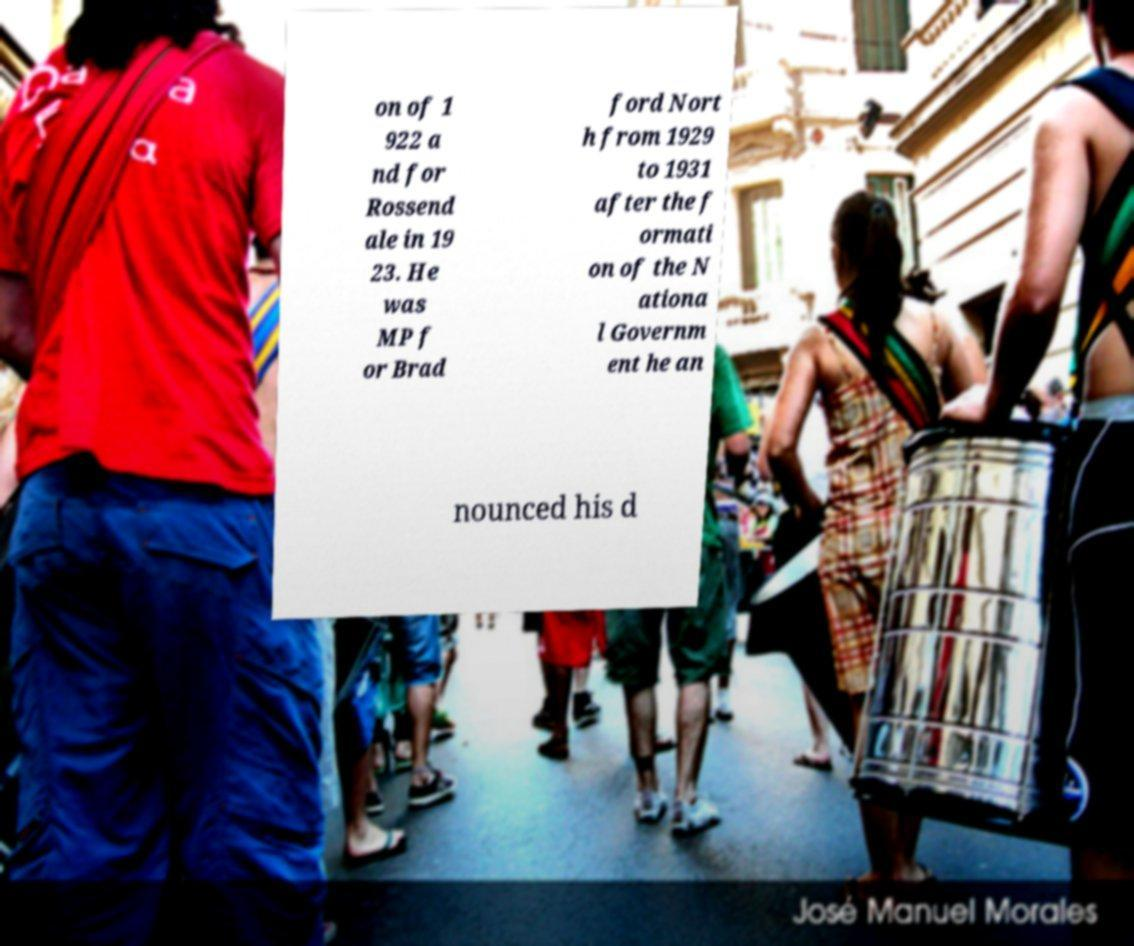I need the written content from this picture converted into text. Can you do that? on of 1 922 a nd for Rossend ale in 19 23. He was MP f or Brad ford Nort h from 1929 to 1931 after the f ormati on of the N ationa l Governm ent he an nounced his d 